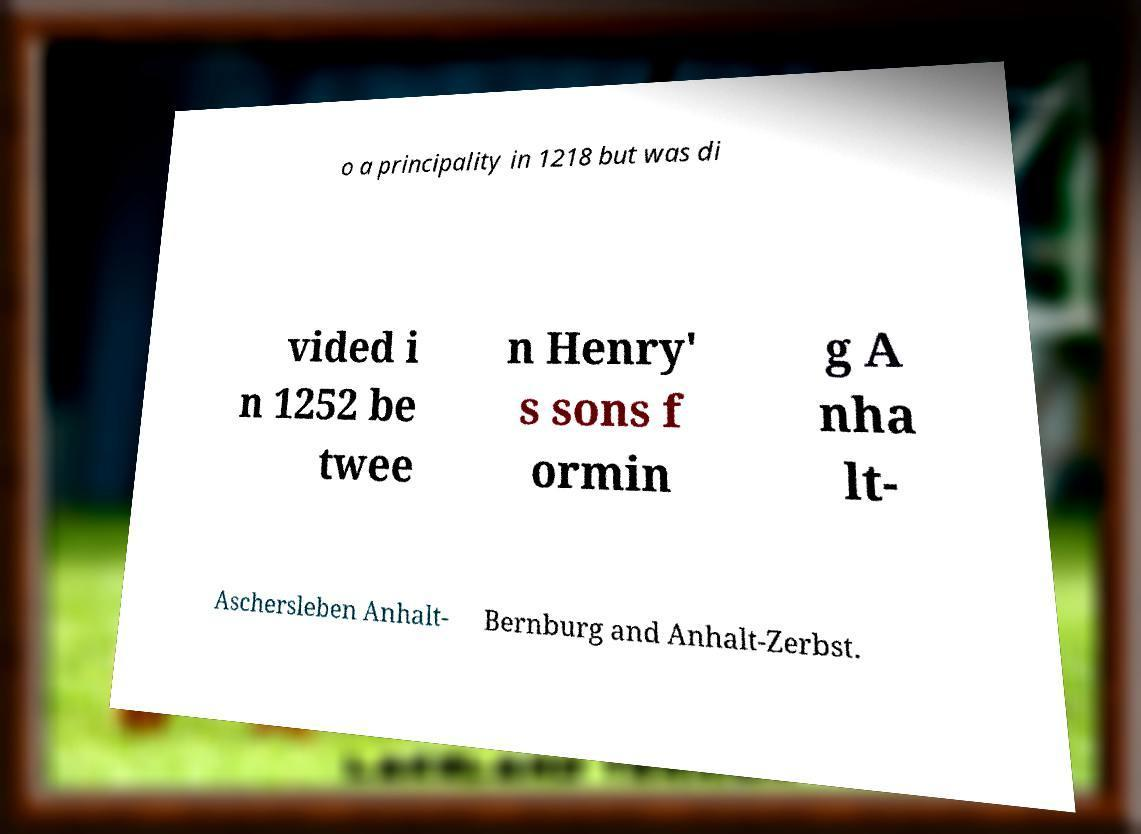I need the written content from this picture converted into text. Can you do that? o a principality in 1218 but was di vided i n 1252 be twee n Henry' s sons f ormin g A nha lt- Aschersleben Anhalt- Bernburg and Anhalt-Zerbst. 